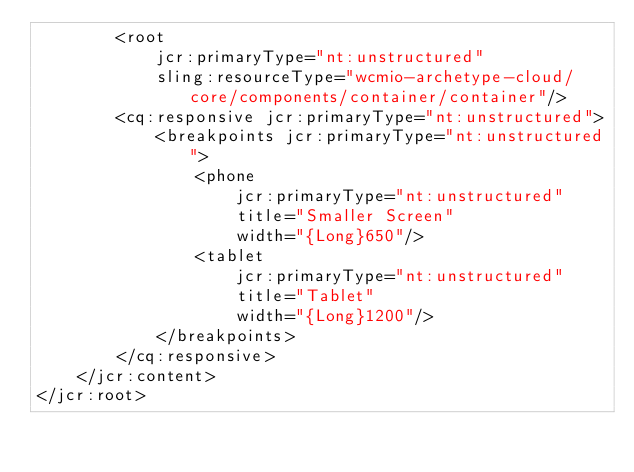<code> <loc_0><loc_0><loc_500><loc_500><_XML_>        <root
            jcr:primaryType="nt:unstructured"
            sling:resourceType="wcmio-archetype-cloud/core/components/container/container"/>
        <cq:responsive jcr:primaryType="nt:unstructured">
            <breakpoints jcr:primaryType="nt:unstructured">
                <phone
                    jcr:primaryType="nt:unstructured"
                    title="Smaller Screen"
                    width="{Long}650"/>
                <tablet
                    jcr:primaryType="nt:unstructured"
                    title="Tablet"
                    width="{Long}1200"/>
            </breakpoints>
        </cq:responsive>
    </jcr:content>
</jcr:root>
</code> 